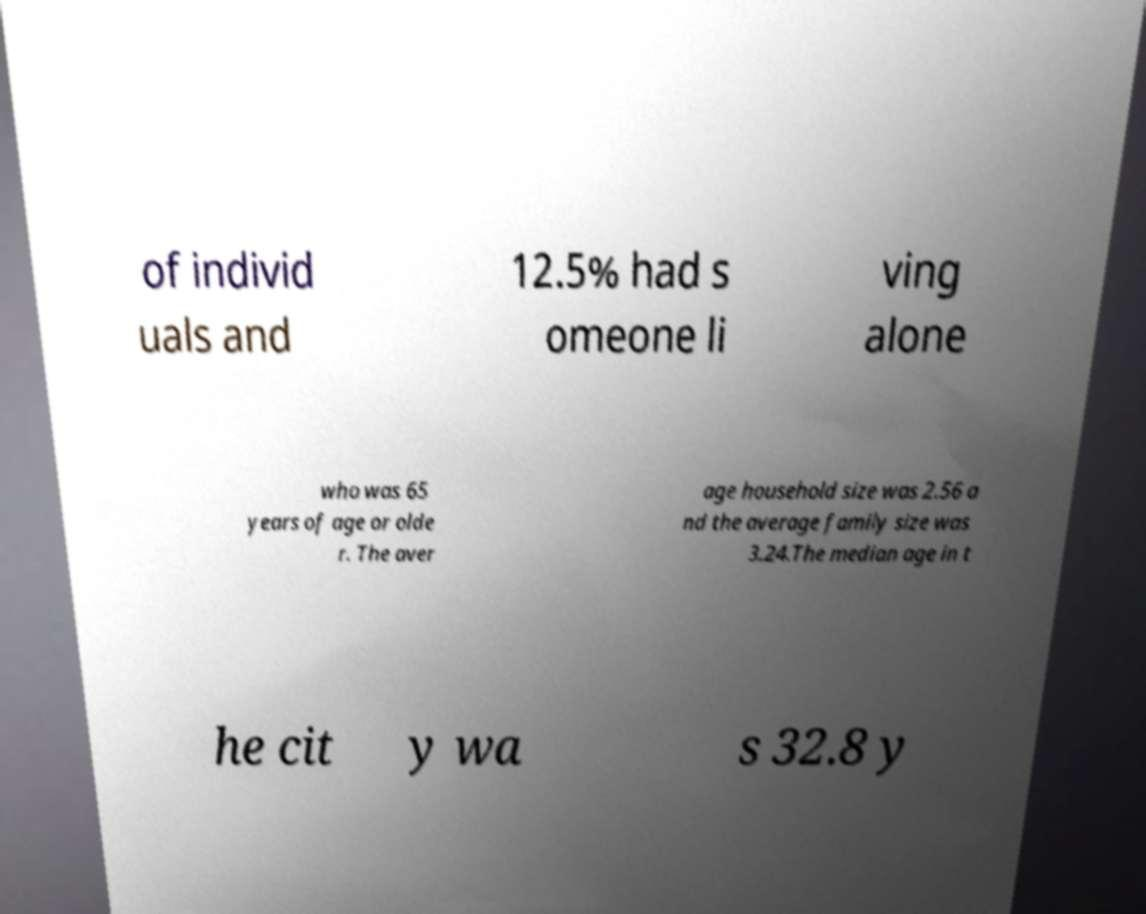Could you extract and type out the text from this image? of individ uals and 12.5% had s omeone li ving alone who was 65 years of age or olde r. The aver age household size was 2.56 a nd the average family size was 3.24.The median age in t he cit y wa s 32.8 y 